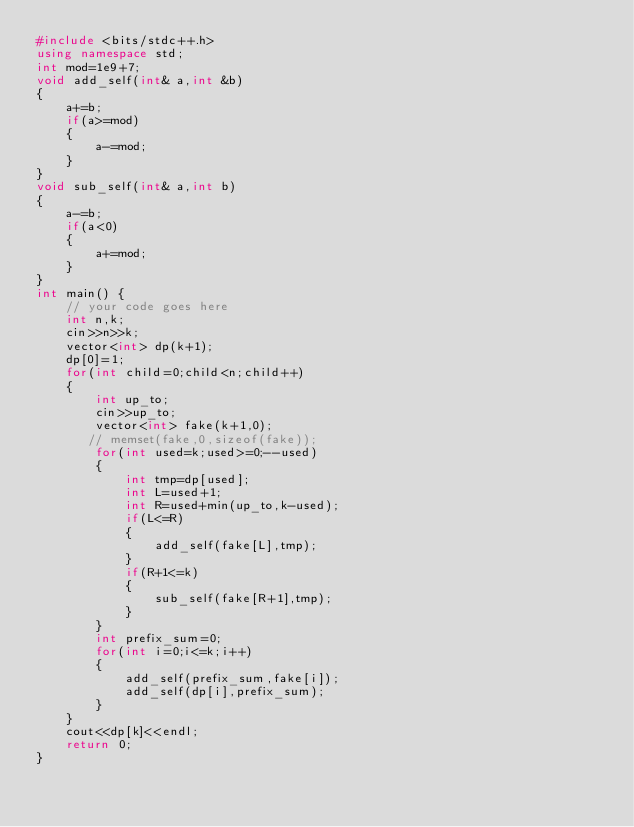<code> <loc_0><loc_0><loc_500><loc_500><_C++_>#include <bits/stdc++.h>
using namespace std;
int mod=1e9+7;
void add_self(int& a,int &b)
{
    a+=b;
    if(a>=mod)
    {
        a-=mod;
    }
}
void sub_self(int& a,int b)
{
    a-=b;
    if(a<0)
    {
        a+=mod;
    }
}
int main() {
	// your code goes here
	int n,k;
	cin>>n>>k;
	vector<int> dp(k+1);
	dp[0]=1;
	for(int child=0;child<n;child++)
	{
	    int up_to;
	    cin>>up_to;
	    vector<int> fake(k+1,0);
	   // memset(fake,0,sizeof(fake));
	    for(int used=k;used>=0;--used)
	    {
	        int tmp=dp[used];
	        int L=used+1;
	        int R=used+min(up_to,k-used);
	        if(L<=R)
	        {
	            add_self(fake[L],tmp);
	        }
	        if(R+1<=k)
	        {
	            sub_self(fake[R+1],tmp);
	        }
	    }
	    int prefix_sum=0;
	    for(int i=0;i<=k;i++)
	    {
	        add_self(prefix_sum,fake[i]);
	        add_self(dp[i],prefix_sum);
	    }
	}
	cout<<dp[k]<<endl;
	return 0;
}
</code> 